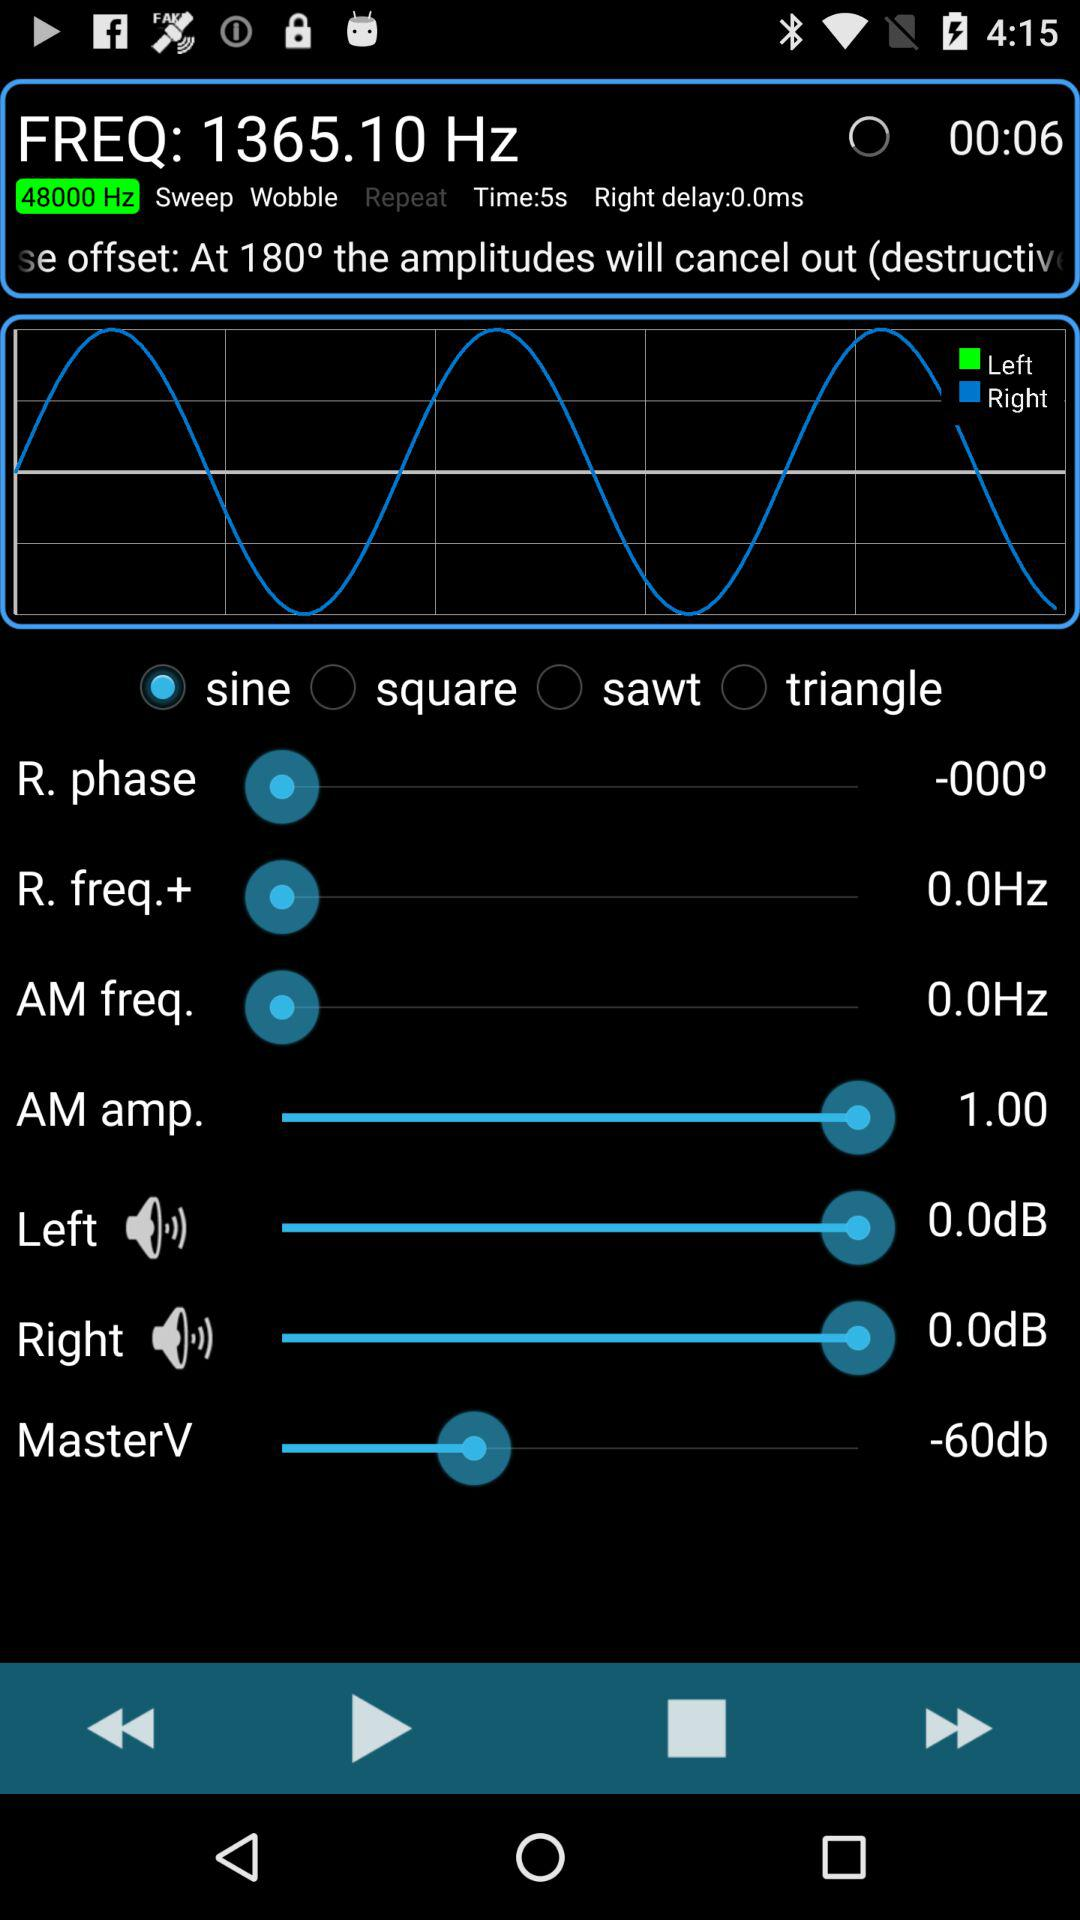How much db is the "MasterV" set to? The "MasterV" is set to -60 decibels. 